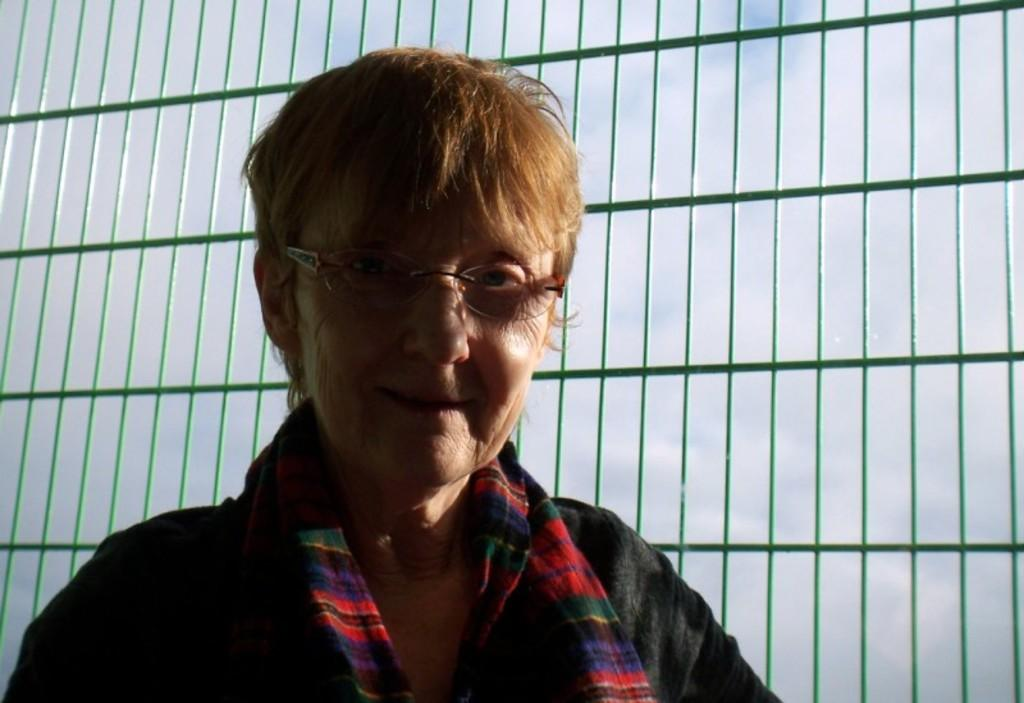Who or what is present in the image? There is a person in the image. Can you describe the person's appearance? The person is wearing clothes and spectacles. What else can be seen in the image? There are grills in the image. What type of substance is the person using to play volleyball in the image? There is no volleyball or substance present in the image; it only features a person wearing clothes and spectacles, along with grills. 